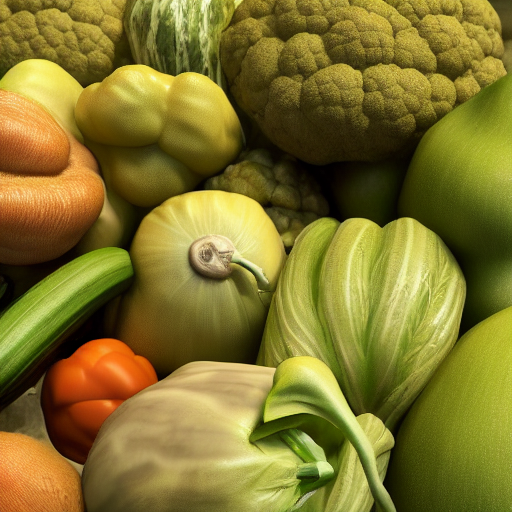Could you tell me more about the snail's role in this image? Certainly, the snail serves as a focal point that draws attention due to its unexpected presence among the vegetables. Its slow-paced nature contrasts with the raw energy suggested by the fresh produce. It also introduces a narrative element, implying a subtle interaction between the flora and fauna. And why do you think the photographer included it in the scene? The photographer likely included the snail to add intrigue and dimension to the composition. It breaks the predictability of a still life of vegetables and introduces the concept of life and movement, hinting at an ecosystem where each element plays a role. 